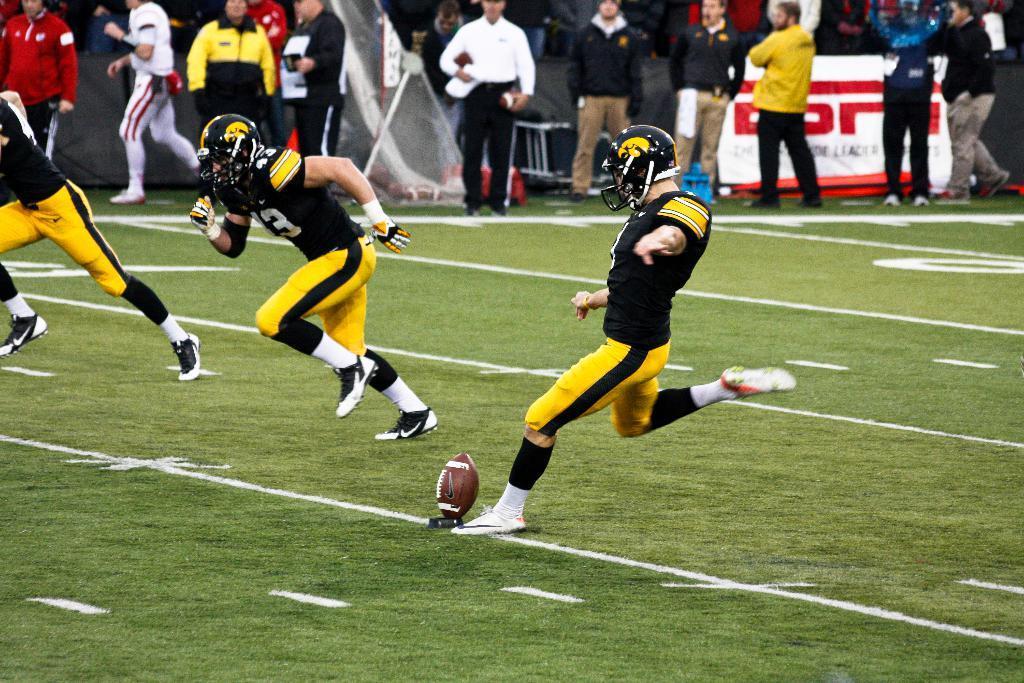Describe this image in one or two sentences. This image is taken outdoors. At the bottom of the image there is a ground with grass on it. In the middle of the image a man is running on the ground and he is about to kick a ball. On the left side of the image two men are running on the ground. In the background a few people are standing on the ground and there is a board with a text on it. 